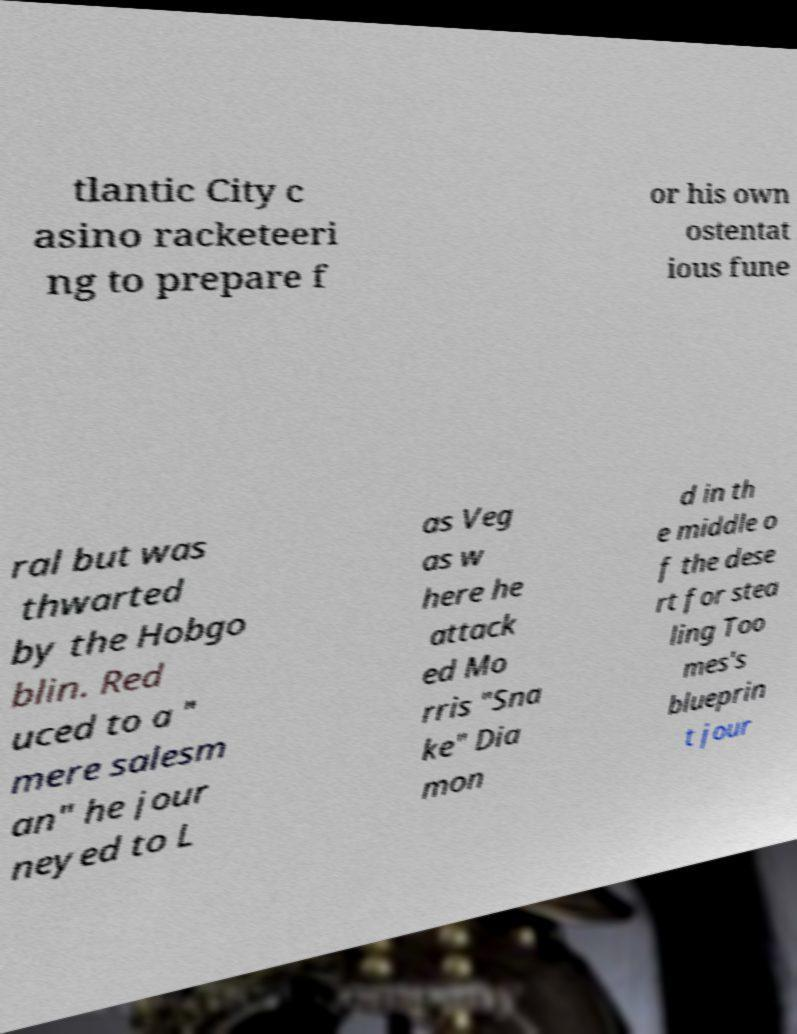Could you extract and type out the text from this image? tlantic City c asino racketeeri ng to prepare f or his own ostentat ious fune ral but was thwarted by the Hobgo blin. Red uced to a " mere salesm an" he jour neyed to L as Veg as w here he attack ed Mo rris "Sna ke" Dia mon d in th e middle o f the dese rt for stea ling Too mes's blueprin t jour 